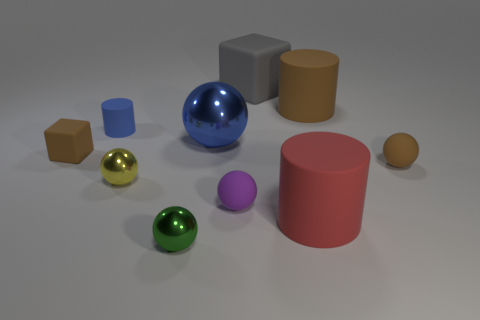The small brown object that is right of the matte block that is left of the matte sphere in front of the brown ball is what shape?
Your response must be concise. Sphere. Is the number of big blue objects greater than the number of cyan metallic objects?
Provide a short and direct response. Yes. What material is the big red thing that is the same shape as the small blue thing?
Offer a terse response. Rubber. Are the brown sphere and the yellow sphere made of the same material?
Offer a terse response. No. Is the number of small yellow objects behind the brown cube greater than the number of brown rubber cylinders?
Your answer should be very brief. No. The brown object behind the sphere behind the small brown object left of the small brown sphere is made of what material?
Keep it short and to the point. Rubber. What number of things are small spheres or brown things that are on the left side of the big brown rubber cylinder?
Your answer should be compact. 5. There is a matte cylinder left of the red cylinder; does it have the same color as the big block?
Provide a succinct answer. No. Is the number of blue things in front of the green thing greater than the number of tiny cylinders that are right of the big rubber cube?
Your answer should be very brief. No. Is there any other thing that has the same color as the big sphere?
Ensure brevity in your answer.  Yes. 